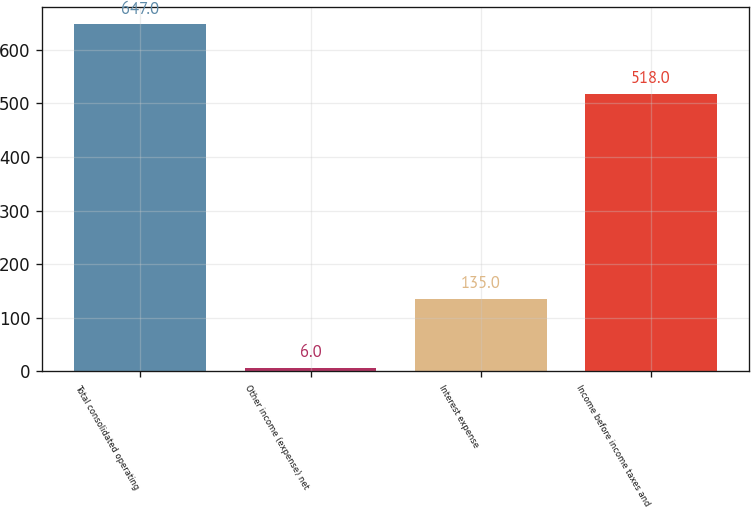Convert chart. <chart><loc_0><loc_0><loc_500><loc_500><bar_chart><fcel>Total consolidated operating<fcel>Other income (expense) net<fcel>Interest expense<fcel>Income before income taxes and<nl><fcel>647<fcel>6<fcel>135<fcel>518<nl></chart> 